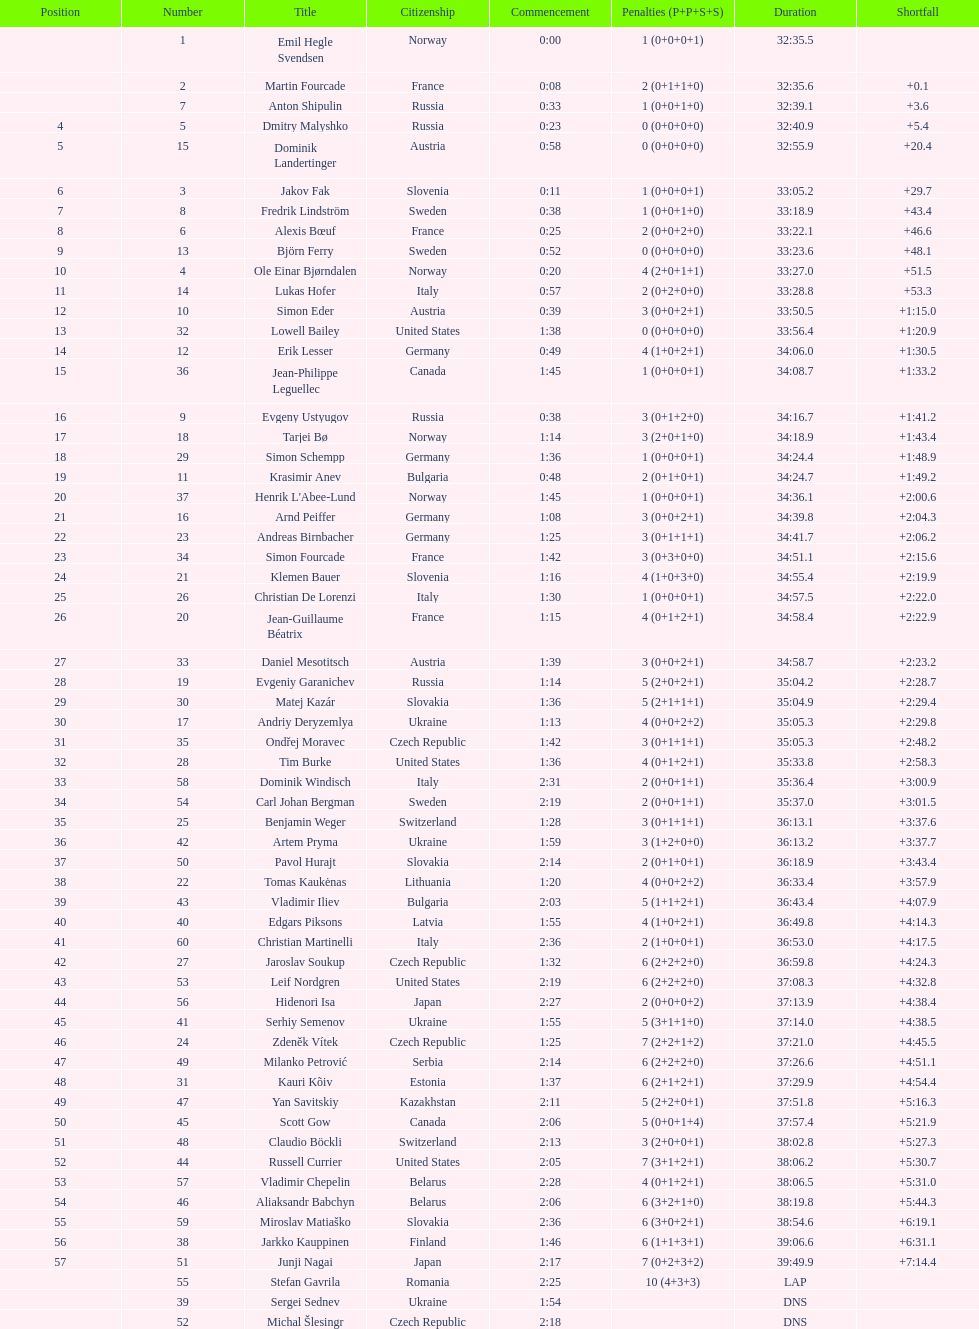What is the combined number of participants from norway and france? 7. 